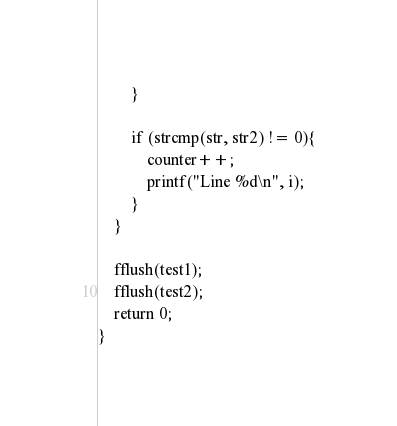<code> <loc_0><loc_0><loc_500><loc_500><_C++_>        }

        if (strcmp(str, str2) != 0){
            counter++;
            printf("Line %d\n", i);
        }
    }

    fflush(test1);
    fflush(test2);
    return 0;
}
</code> 